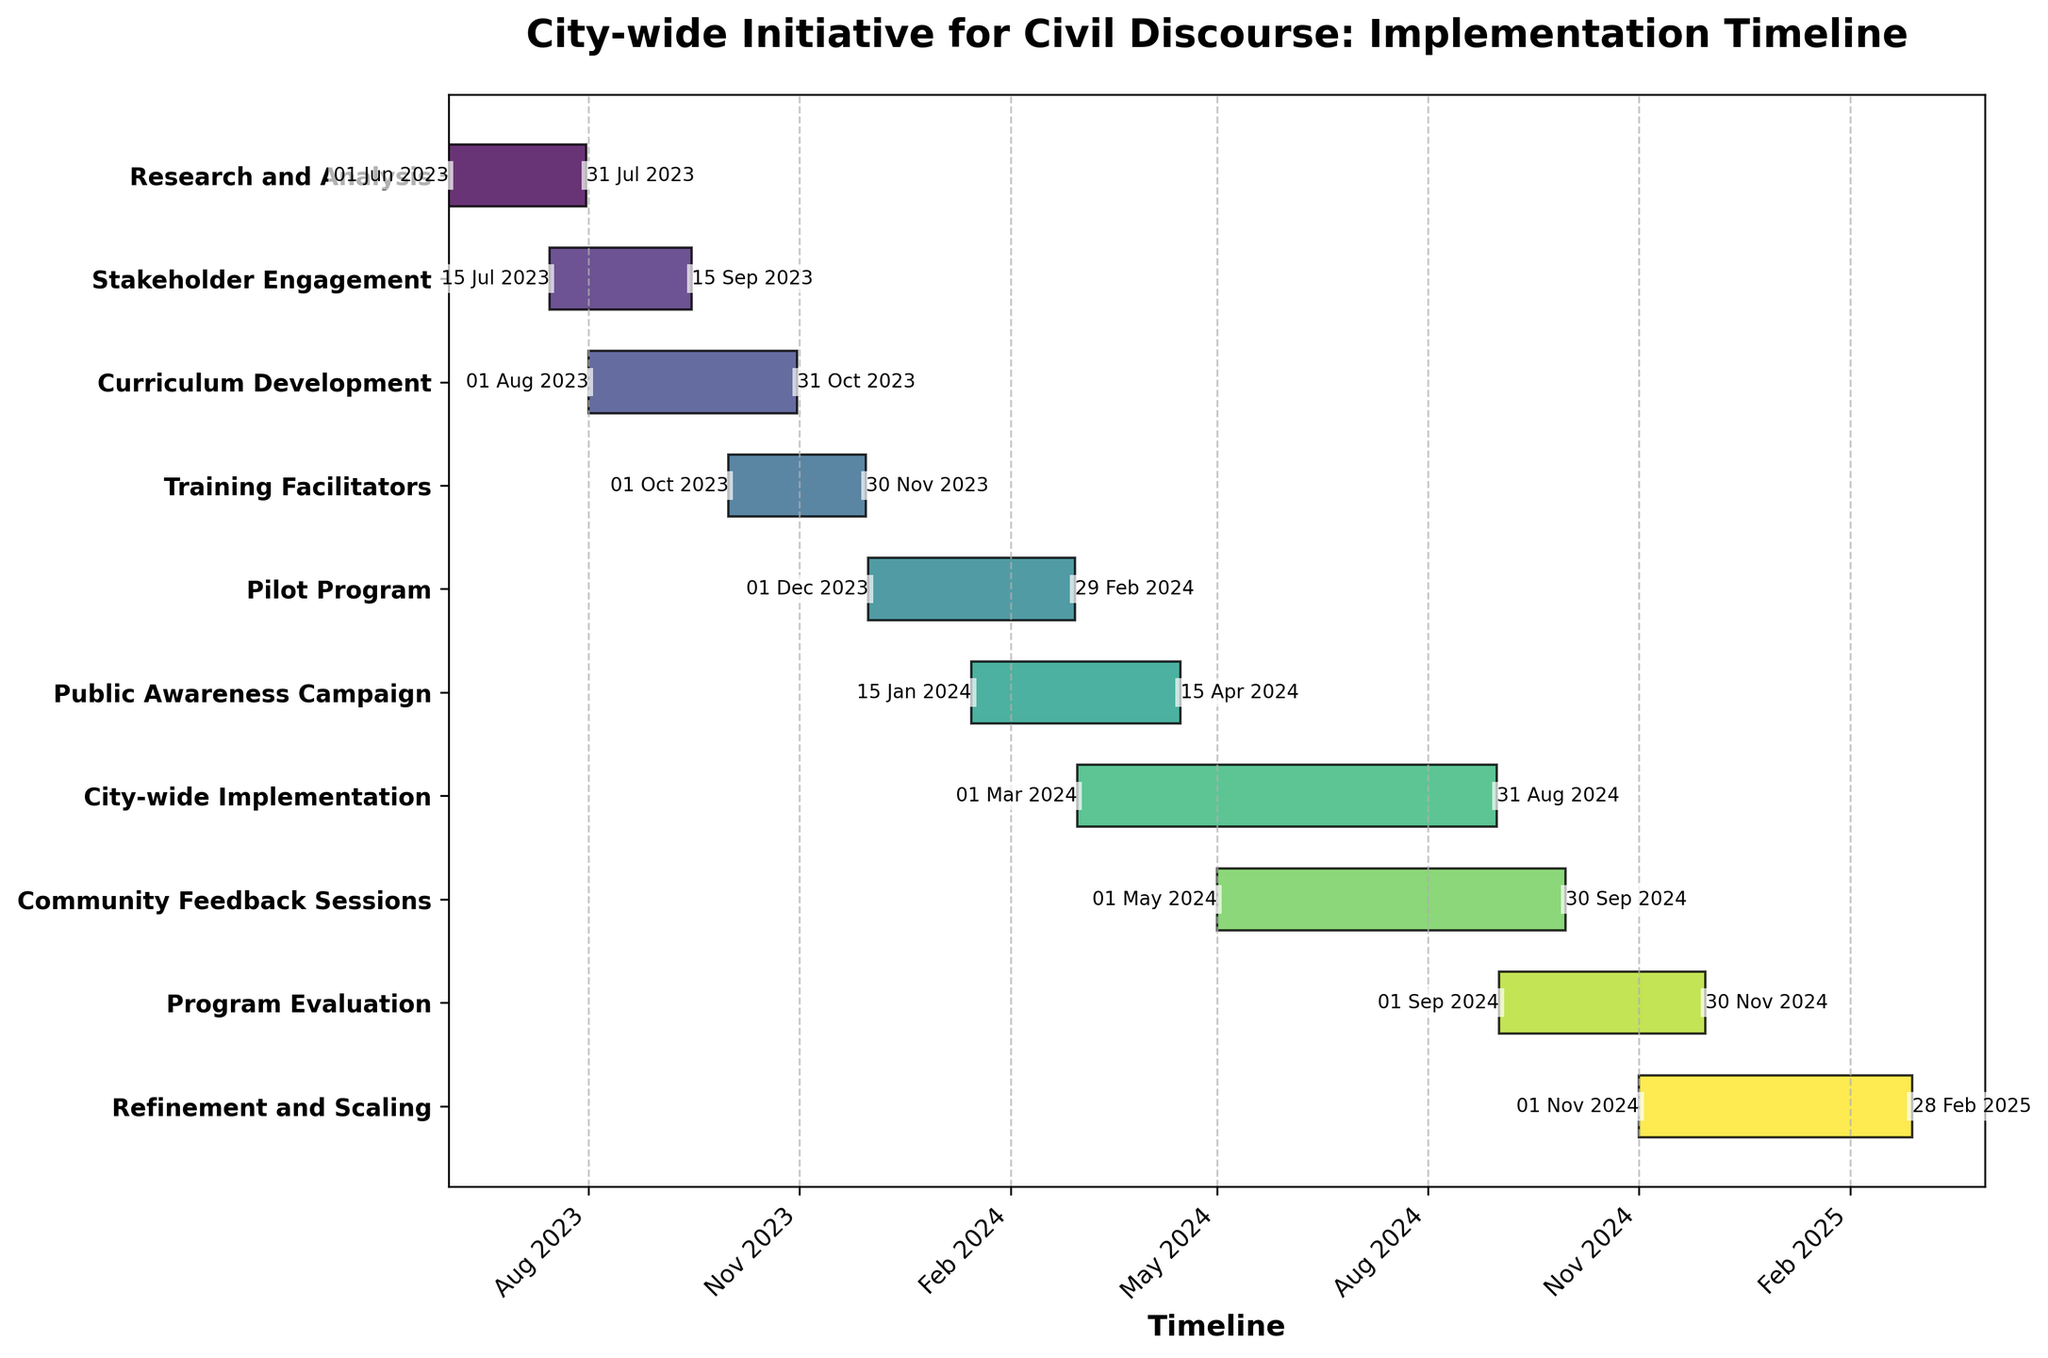How many tasks are included in the city-wide initiative? To find the number of tasks, count the number of horizontal bars in the plot. Each bar represents a task.
Answer: 10 What is the title of the project represented by the Gantt chart? The title of the project is displayed at the top of the chart in bold. Read the text to find the title.
Answer: City-wide Initiative for Civil Discourse: Implementation Timeline Which task has the longest duration? To determine the task with the longest duration, compare the lengths of the horizontal bars. The longest bar corresponds to the longest task.
Answer: City-wide Implementation When does the Pilot Program start and end? Find the horizontal bar labeled "Pilot Program" and look at the start and end date annotations on either side of the bar.
Answer: 01 Dec 2023 to 29 Feb 2024 How does the duration of Stakeholder Engagement compare to Research and Analysis? Measure the lengths of the horizontal bars for each task. Subtract the start date from the end date to find each task's duration. Compare the two results to determine which is longer.
Answer: Stakeholder Engagement is longer Does the Public Awareness Campaign overlap with the City-wide Implementation phase? Identify the start and end dates for both tasks in the Gantt chart. Check if any dates in the Public Awareness Campaign's duration fall within the City-wide Implementation phase.
Answer: Yes How far apart are the start dates for Research and Analysis and Training Facilitators? Find the start dates for both tasks and calculate the difference between these dates.
Answer: 122 days Which tasks have overlapping timelines with the Curriculum Development phase? Identify the start and end dates for Curriculum Development. Find other tasks that have parts of their durations within this timeframe.
Answer: Stakeholder Engagement, Training Facilitators, Pilot Program What is the average duration of all the tasks? Calculate the duration for each task. Sum these durations and divide by the number of tasks to find the average.
Answer: 138.5 days Which phase follows immediately after Program Evaluation? Identify the end date of the Program Evaluation phase and find the task that starts on or shortly after this date.
Answer: Refinement and Scaling 